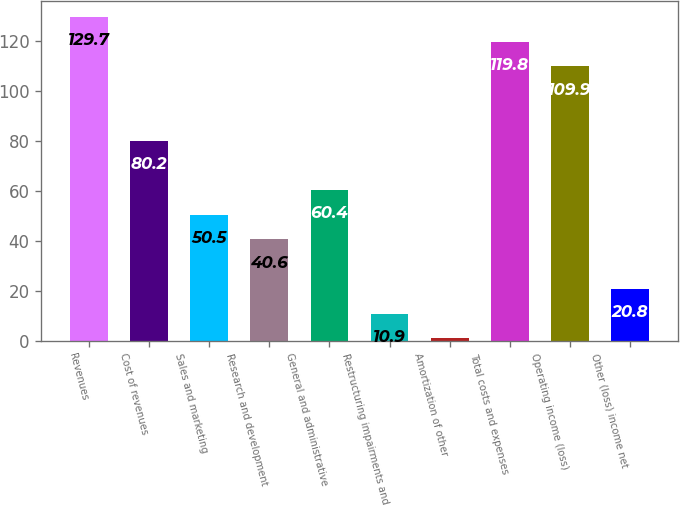<chart> <loc_0><loc_0><loc_500><loc_500><bar_chart><fcel>Revenues<fcel>Cost of revenues<fcel>Sales and marketing<fcel>Research and development<fcel>General and administrative<fcel>Restructuring impairments and<fcel>Amortization of other<fcel>Total costs and expenses<fcel>Operating income (loss)<fcel>Other (loss) income net<nl><fcel>129.7<fcel>80.2<fcel>50.5<fcel>40.6<fcel>60.4<fcel>10.9<fcel>1<fcel>119.8<fcel>109.9<fcel>20.8<nl></chart> 